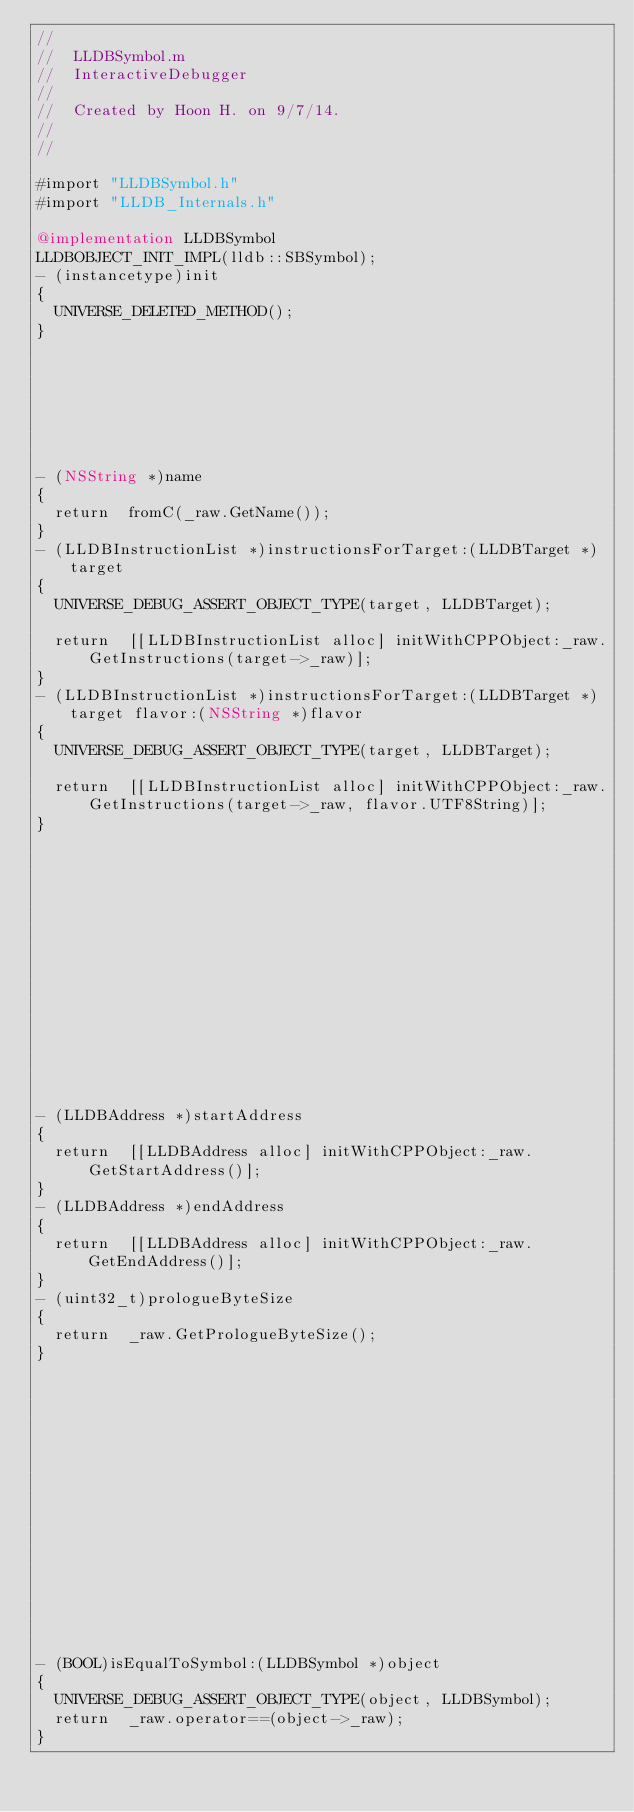Convert code to text. <code><loc_0><loc_0><loc_500><loc_500><_ObjectiveC_>//
//  LLDBSymbol.m
//  InteractiveDebugger
//
//  Created by Hoon H. on 9/7/14.
//
//

#import "LLDBSymbol.h"
#import "LLDB_Internals.h"

@implementation LLDBSymbol
LLDBOBJECT_INIT_IMPL(lldb::SBSymbol);
- (instancetype)init
{
	UNIVERSE_DELETED_METHOD();
}







- (NSString *)name
{
	return	fromC(_raw.GetName());
}
- (LLDBInstructionList *)instructionsForTarget:(LLDBTarget *)target
{
	UNIVERSE_DEBUG_ASSERT_OBJECT_TYPE(target, LLDBTarget);
	
	return	[[LLDBInstructionList alloc] initWithCPPObject:_raw.GetInstructions(target->_raw)];
}
- (LLDBInstructionList *)instructionsForTarget:(LLDBTarget *)target flavor:(NSString *)flavor
{
	UNIVERSE_DEBUG_ASSERT_OBJECT_TYPE(target, LLDBTarget);
	
	return	[[LLDBInstructionList alloc] initWithCPPObject:_raw.GetInstructions(target->_raw, flavor.UTF8String)];
}















- (LLDBAddress *)startAddress
{
	return	[[LLDBAddress alloc] initWithCPPObject:_raw.GetStartAddress()];
}
- (LLDBAddress *)endAddress
{
	return	[[LLDBAddress alloc] initWithCPPObject:_raw.GetEndAddress()];
}
- (uint32_t)prologueByteSize
{
	return	_raw.GetPrologueByteSize();
}
















- (BOOL)isEqualToSymbol:(LLDBSymbol *)object
{
	UNIVERSE_DEBUG_ASSERT_OBJECT_TYPE(object, LLDBSymbol);
	return	_raw.operator==(object->_raw);
}</code> 